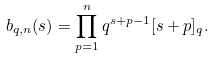Convert formula to latex. <formula><loc_0><loc_0><loc_500><loc_500>b _ { q , n } ( s ) = \prod _ { p = 1 } ^ { n } q ^ { s + p - 1 } [ s + p ] _ { q } .</formula> 